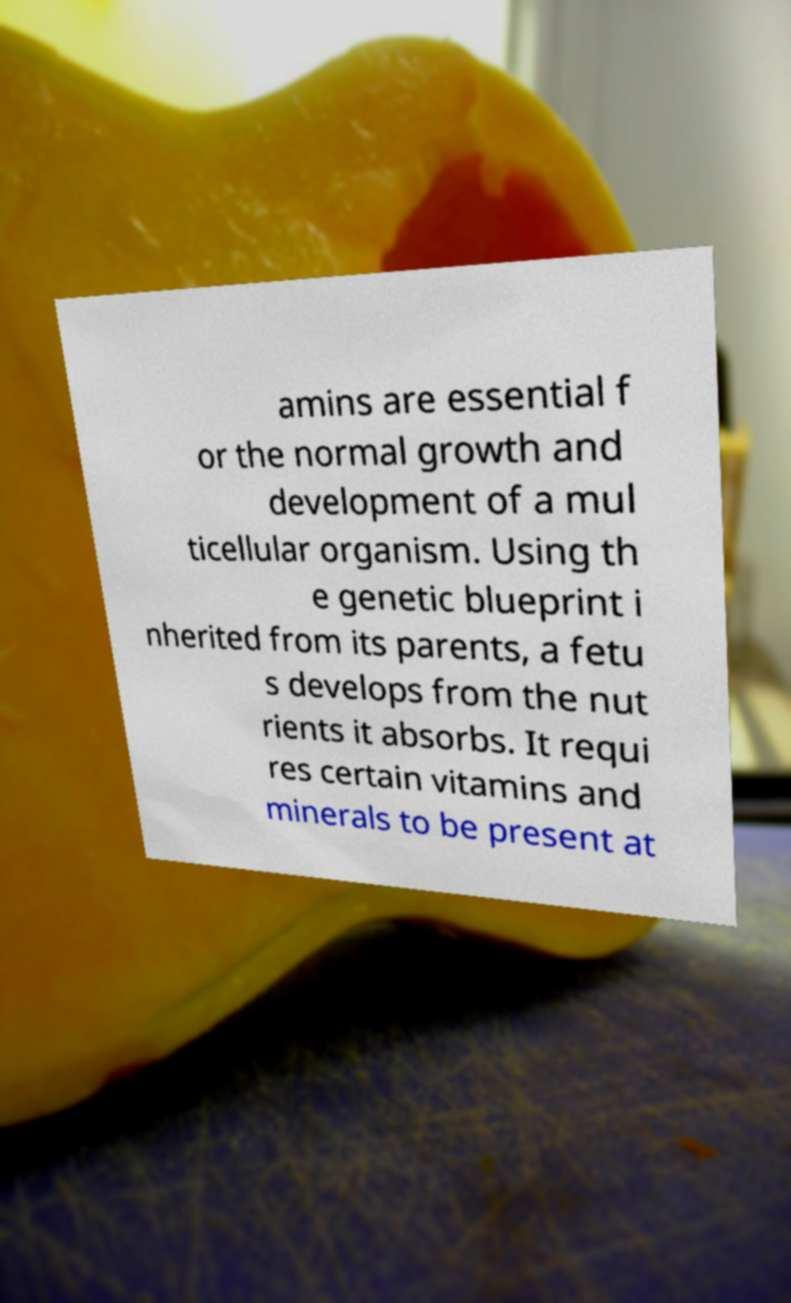Could you extract and type out the text from this image? amins are essential f or the normal growth and development of a mul ticellular organism. Using th e genetic blueprint i nherited from its parents, a fetu s develops from the nut rients it absorbs. It requi res certain vitamins and minerals to be present at 